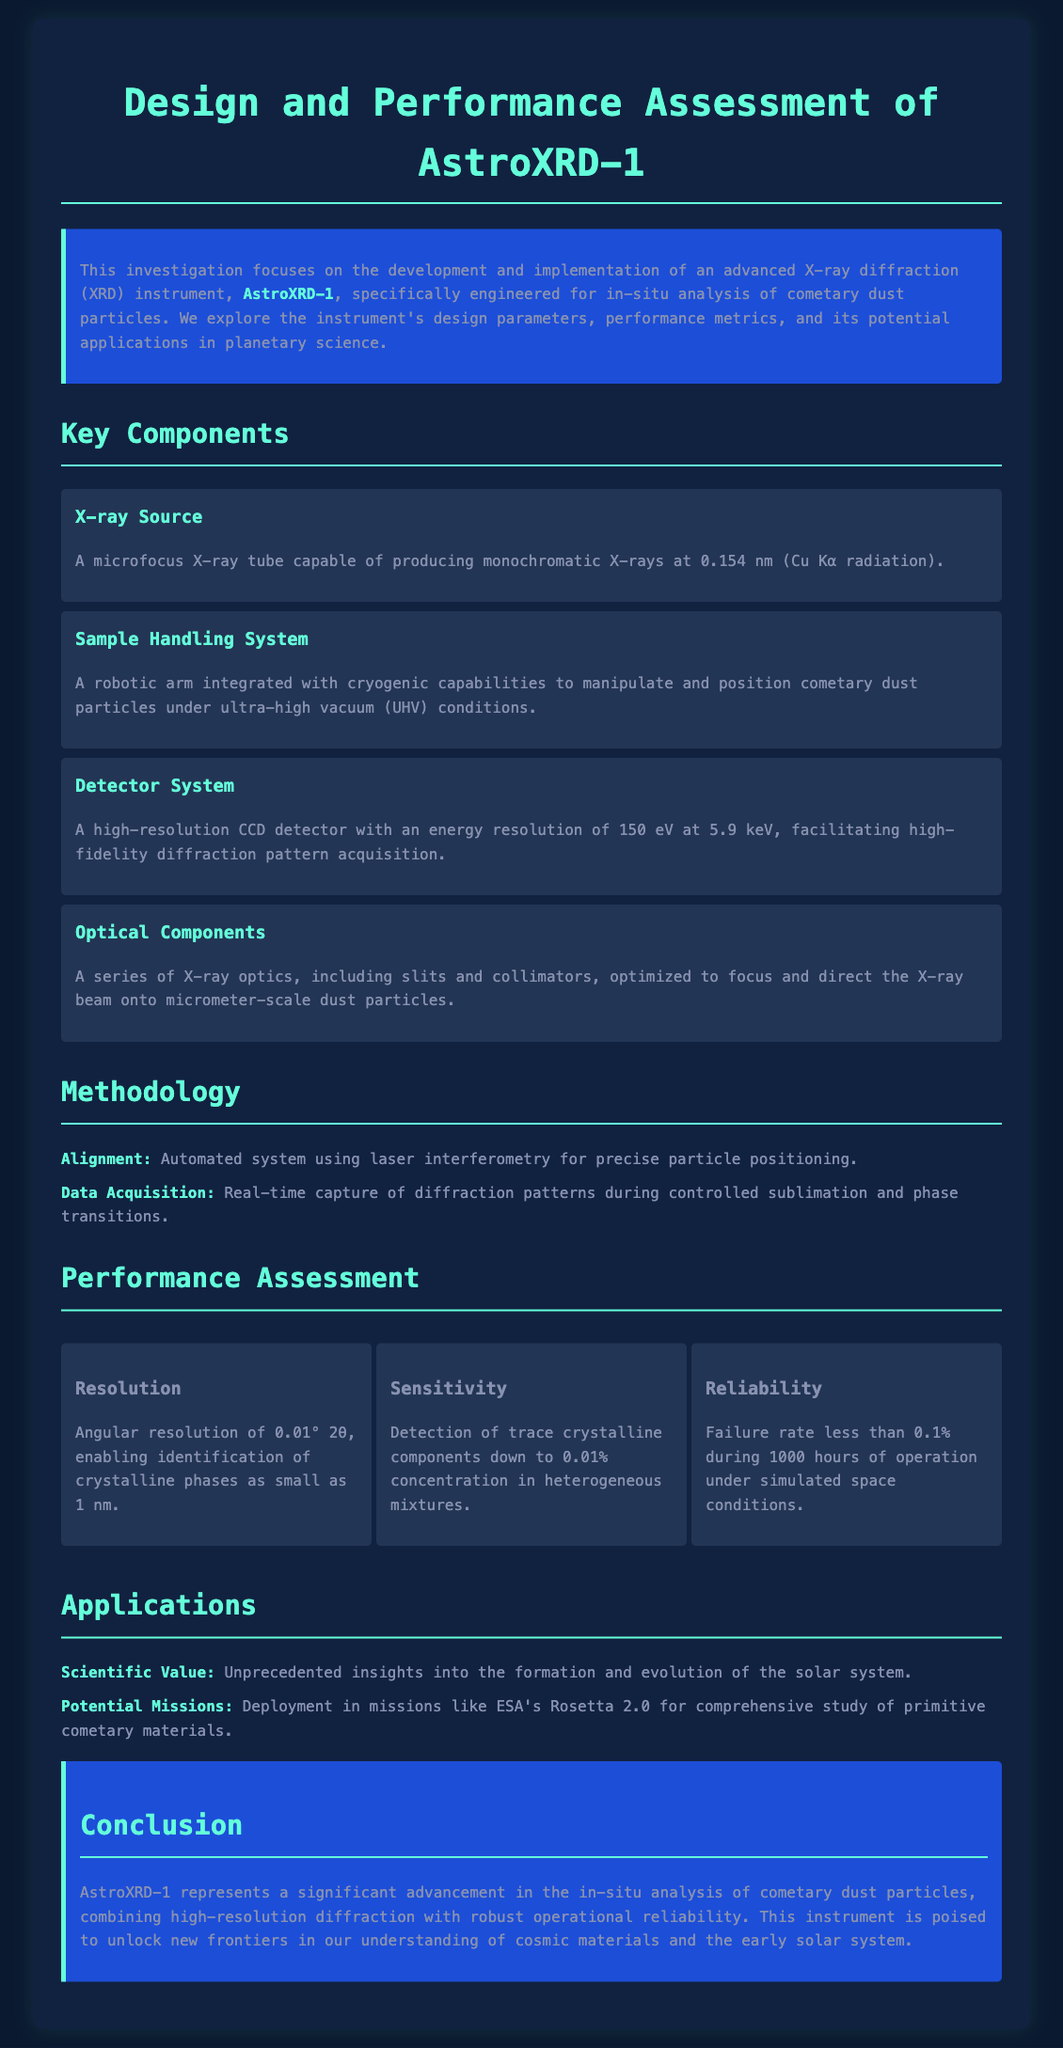What is the name of the instrument developed for analyzing cometary dust? The instrument designed for this purpose is named AstroXRD-1.
Answer: AstroXRD-1 What type of X-ray radiation does the microfocus X-ray tube produce? The microfocus X-ray tube generates Cu Kα radiation at a wavelength of 0.154 nm.
Answer: Cu Kα radiation What is the angular resolution of AstroXRD-1? The angular resolution of the instrument is 0.01° 2θ.
Answer: 0.01° 2θ What detection limit does AstroXRD-1 have for trace crystalline components? The sensitivity allows for detection of components down to 0.01% concentration.
Answer: 0.01% What is the failure rate of AstroXRD-1 during operation under simulated space conditions? The failure rate of the instrument is less than 0.1% during operation.
Answer: Less than 0.1% What innovative system is used for particle positioning? A laser interferometry-based automated alignment system is utilized for precise positioning.
Answer: Laser interferometry What key applications are mentioned for AstroXRD-1? The applications include providing insights into the formation and evolution of the solar system.
Answer: Insights into solar system formation How long can AstroXRD-1 operate under simulated conditions before failure occurs? The performance assessment states it can operate for 1000 hours before failure occurs.
Answer: 1000 hours 